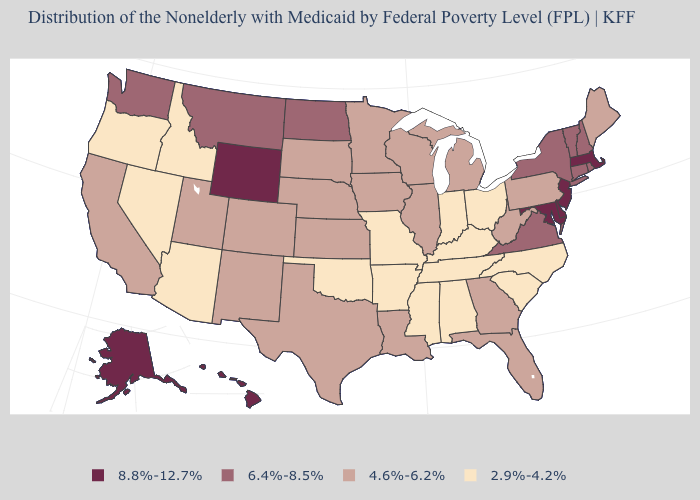Does the map have missing data?
Write a very short answer. No. Name the states that have a value in the range 4.6%-6.2%?
Be succinct. California, Colorado, Florida, Georgia, Illinois, Iowa, Kansas, Louisiana, Maine, Michigan, Minnesota, Nebraska, New Mexico, Pennsylvania, South Dakota, Texas, Utah, West Virginia, Wisconsin. What is the value of Maryland?
Answer briefly. 8.8%-12.7%. Name the states that have a value in the range 2.9%-4.2%?
Be succinct. Alabama, Arizona, Arkansas, Idaho, Indiana, Kentucky, Mississippi, Missouri, Nevada, North Carolina, Ohio, Oklahoma, Oregon, South Carolina, Tennessee. What is the value of Oregon?
Be succinct. 2.9%-4.2%. Does Pennsylvania have the same value as Alaska?
Write a very short answer. No. Does the map have missing data?
Keep it brief. No. Does Minnesota have a higher value than Washington?
Quick response, please. No. What is the value of Massachusetts?
Write a very short answer. 8.8%-12.7%. Name the states that have a value in the range 8.8%-12.7%?
Be succinct. Alaska, Delaware, Hawaii, Maryland, Massachusetts, New Jersey, Wyoming. Name the states that have a value in the range 4.6%-6.2%?
Keep it brief. California, Colorado, Florida, Georgia, Illinois, Iowa, Kansas, Louisiana, Maine, Michigan, Minnesota, Nebraska, New Mexico, Pennsylvania, South Dakota, Texas, Utah, West Virginia, Wisconsin. What is the lowest value in the USA?
Give a very brief answer. 2.9%-4.2%. Name the states that have a value in the range 4.6%-6.2%?
Concise answer only. California, Colorado, Florida, Georgia, Illinois, Iowa, Kansas, Louisiana, Maine, Michigan, Minnesota, Nebraska, New Mexico, Pennsylvania, South Dakota, Texas, Utah, West Virginia, Wisconsin. What is the value of Maine?
Quick response, please. 4.6%-6.2%. Does Massachusetts have the highest value in the USA?
Quick response, please. Yes. 